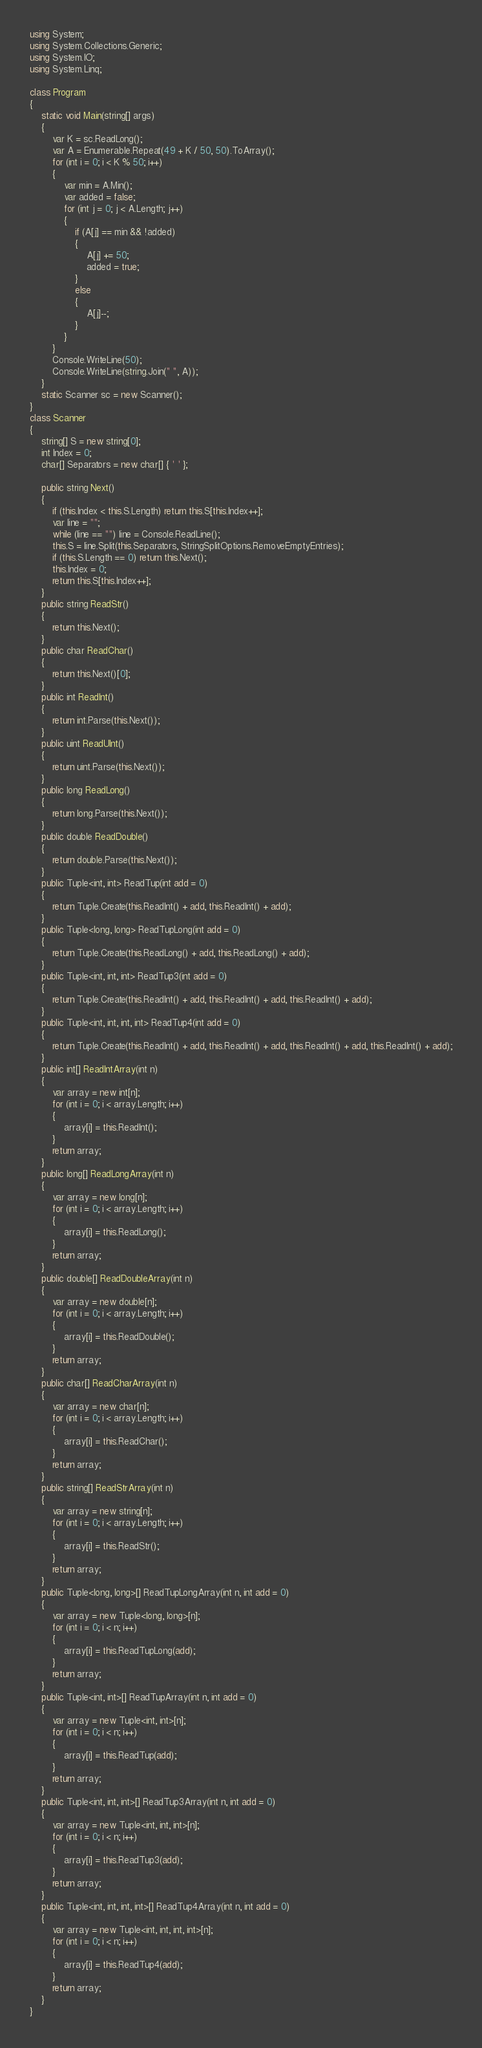Convert code to text. <code><loc_0><loc_0><loc_500><loc_500><_C#_>using System;
using System.Collections.Generic;
using System.IO;
using System.Linq;

class Program
{
    static void Main(string[] args)
    {
        var K = sc.ReadLong();
        var A = Enumerable.Repeat(49 + K / 50, 50).ToArray();
        for (int i = 0; i < K % 50; i++)
        {
            var min = A.Min();
            var added = false;
            for (int j = 0; j < A.Length; j++)
            {
                if (A[j] == min && !added)
                {
                    A[j] += 50;
                    added = true;
                }
                else
                {
                    A[j]--;
                }
            }
        }
        Console.WriteLine(50);
        Console.WriteLine(string.Join(" ", A));
    }
    static Scanner sc = new Scanner();
}
class Scanner
{
    string[] S = new string[0];
    int Index = 0;
    char[] Separators = new char[] { ' ' };

    public string Next()
    {
        if (this.Index < this.S.Length) return this.S[this.Index++];
        var line = "";
        while (line == "") line = Console.ReadLine();
        this.S = line.Split(this.Separators, StringSplitOptions.RemoveEmptyEntries);
        if (this.S.Length == 0) return this.Next();
        this.Index = 0;
        return this.S[this.Index++];
    }
    public string ReadStr()
    {
        return this.Next();
    }
    public char ReadChar()
    {
        return this.Next()[0];
    }
    public int ReadInt()
    {
        return int.Parse(this.Next());
    }
    public uint ReadUInt()
    {
        return uint.Parse(this.Next());
    }
    public long ReadLong()
    {
        return long.Parse(this.Next());
    }
    public double ReadDouble()
    {
        return double.Parse(this.Next());
    }
    public Tuple<int, int> ReadTup(int add = 0)
    {
        return Tuple.Create(this.ReadInt() + add, this.ReadInt() + add);
    }
    public Tuple<long, long> ReadTupLong(int add = 0)
    {
        return Tuple.Create(this.ReadLong() + add, this.ReadLong() + add);
    }
    public Tuple<int, int, int> ReadTup3(int add = 0)
    {
        return Tuple.Create(this.ReadInt() + add, this.ReadInt() + add, this.ReadInt() + add);
    }
    public Tuple<int, int, int, int> ReadTup4(int add = 0)
    {
        return Tuple.Create(this.ReadInt() + add, this.ReadInt() + add, this.ReadInt() + add, this.ReadInt() + add);
    }
    public int[] ReadIntArray(int n)
    {
        var array = new int[n];
        for (int i = 0; i < array.Length; i++)
        {
            array[i] = this.ReadInt();
        }
        return array;
    }
    public long[] ReadLongArray(int n)
    {
        var array = new long[n];
        for (int i = 0; i < array.Length; i++)
        {
            array[i] = this.ReadLong();
        }
        return array;
    }
    public double[] ReadDoubleArray(int n)
    {
        var array = new double[n];
        for (int i = 0; i < array.Length; i++)
        {
            array[i] = this.ReadDouble();
        }
        return array;
    }
    public char[] ReadCharArray(int n)
    {
        var array = new char[n];
        for (int i = 0; i < array.Length; i++)
        {
            array[i] = this.ReadChar();
        }
        return array;
    }
    public string[] ReadStrArray(int n)
    {
        var array = new string[n];
        for (int i = 0; i < array.Length; i++)
        {
            array[i] = this.ReadStr();
        }
        return array;
    }
    public Tuple<long, long>[] ReadTupLongArray(int n, int add = 0)
    {
        var array = new Tuple<long, long>[n];
        for (int i = 0; i < n; i++)
        {
            array[i] = this.ReadTupLong(add);
        }
        return array;
    }
    public Tuple<int, int>[] ReadTupArray(int n, int add = 0)
    {
        var array = new Tuple<int, int>[n];
        for (int i = 0; i < n; i++)
        {
            array[i] = this.ReadTup(add);
        }
        return array;
    }
    public Tuple<int, int, int>[] ReadTup3Array(int n, int add = 0)
    {
        var array = new Tuple<int, int, int>[n];
        for (int i = 0; i < n; i++)
        {
            array[i] = this.ReadTup3(add);
        }
        return array;
    }
    public Tuple<int, int, int, int>[] ReadTup4Array(int n, int add = 0)
    {
        var array = new Tuple<int, int, int, int>[n];
        for (int i = 0; i < n; i++)
        {
            array[i] = this.ReadTup4(add);
        }
        return array;
    }
}
</code> 